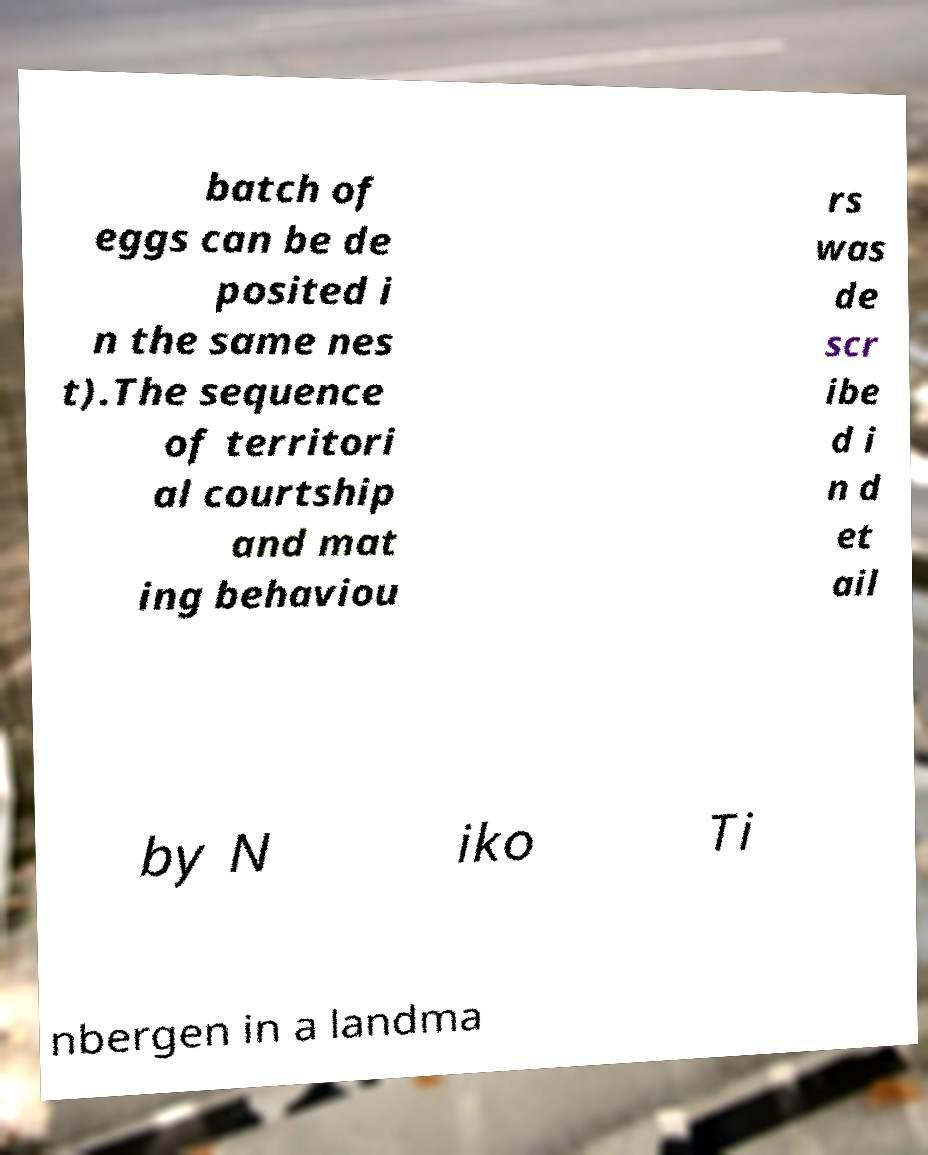Could you assist in decoding the text presented in this image and type it out clearly? batch of eggs can be de posited i n the same nes t).The sequence of territori al courtship and mat ing behaviou rs was de scr ibe d i n d et ail by N iko Ti nbergen in a landma 